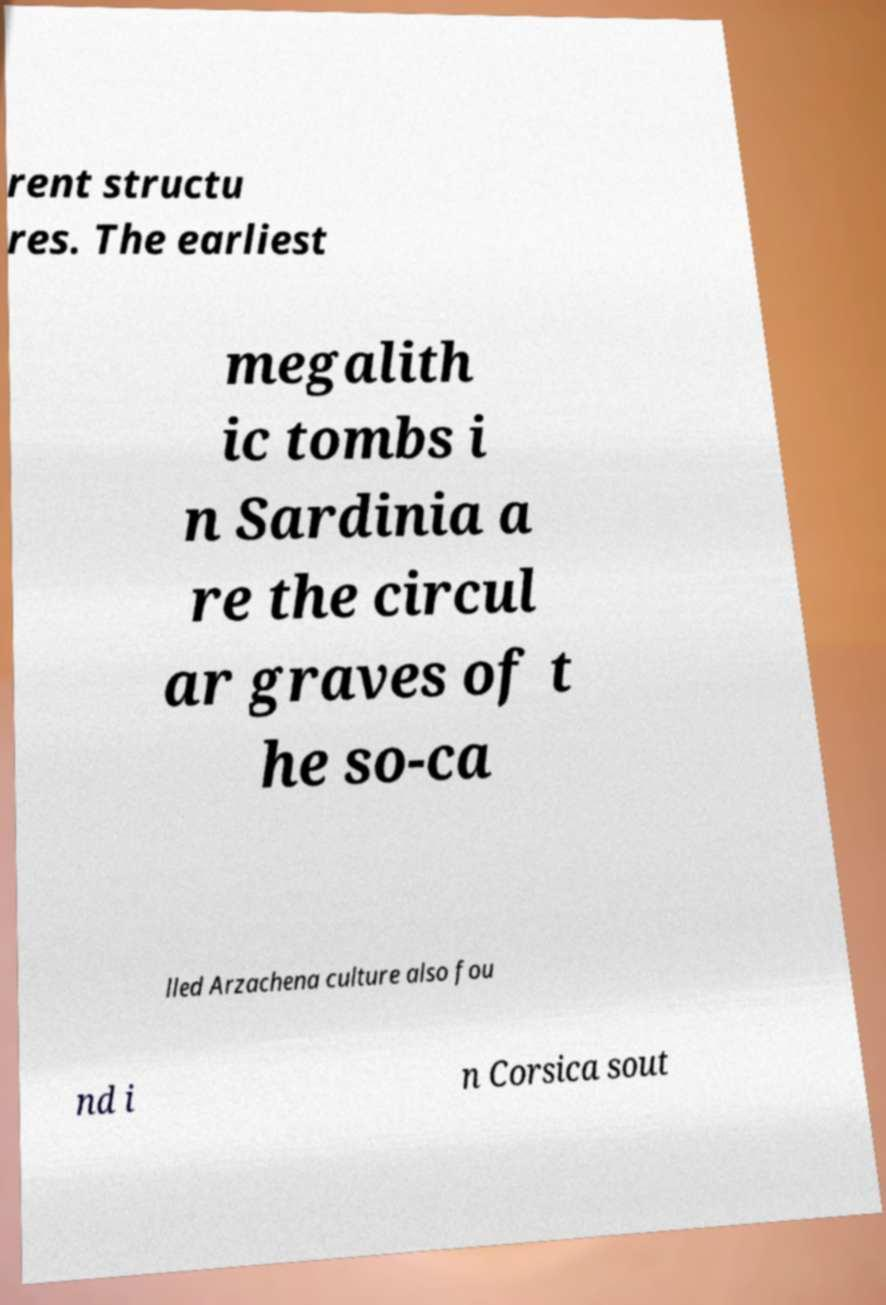What messages or text are displayed in this image? I need them in a readable, typed format. rent structu res. The earliest megalith ic tombs i n Sardinia a re the circul ar graves of t he so-ca lled Arzachena culture also fou nd i n Corsica sout 